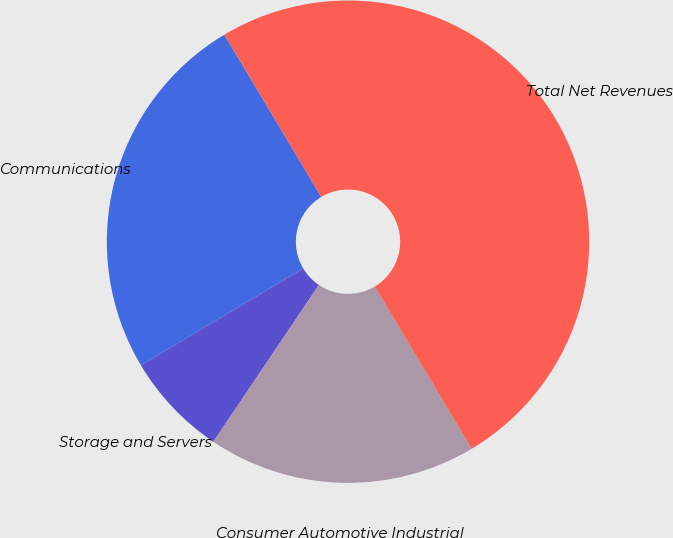Convert chart. <chart><loc_0><loc_0><loc_500><loc_500><pie_chart><fcel>Communications<fcel>Storage and Servers<fcel>Consumer Automotive Industrial<fcel>Total Net Revenues<nl><fcel>25.0%<fcel>7.0%<fcel>18.0%<fcel>50.0%<nl></chart> 